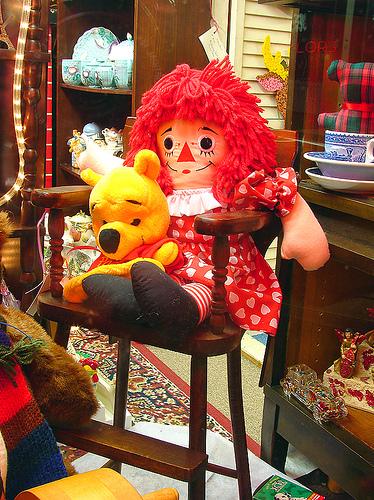Does the doll have a nose?
Concise answer only. Yes. What are the names of the stuffed animals in the high chair?
Be succinct. Raggedy ann and pooh bear. What color is the doll's hair?
Answer briefly. Red. 